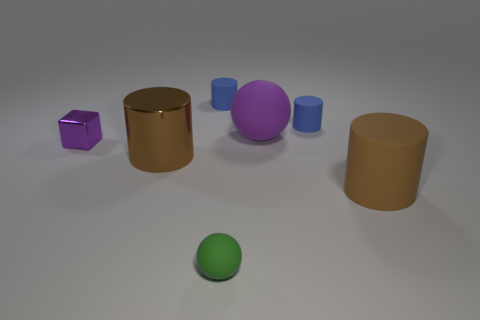How many blue objects are the same size as the brown shiny cylinder?
Your answer should be very brief. 0. The shiny cube that is the same color as the large rubber sphere is what size?
Offer a terse response. Small. There is a rubber sphere that is behind the metal object in front of the small shiny cube; what color is it?
Ensure brevity in your answer.  Purple. Are there any rubber spheres that have the same color as the block?
Give a very brief answer. Yes. The matte sphere that is the same size as the brown shiny cylinder is what color?
Your response must be concise. Purple. Are the big brown cylinder that is to the left of the small matte ball and the big purple sphere made of the same material?
Offer a very short reply. No. There is a big cylinder that is left of the brown cylinder that is on the right side of the metallic cylinder; are there any brown rubber things that are behind it?
Provide a short and direct response. No. There is a tiny matte thing left of the small matte ball; is it the same shape as the green thing?
Give a very brief answer. No. There is a small blue matte object in front of the small blue cylinder to the left of the big purple object; what is its shape?
Your answer should be very brief. Cylinder. What size is the rubber sphere behind the large brown cylinder that is to the right of the sphere on the left side of the big rubber ball?
Provide a succinct answer. Large. 